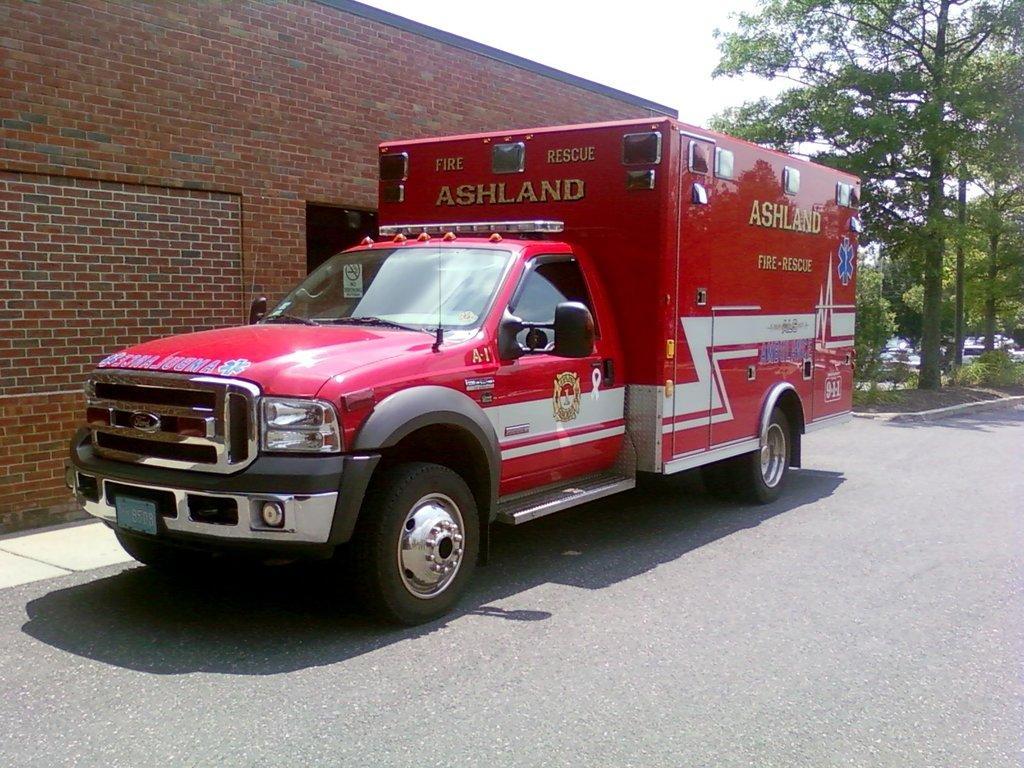Could you give a brief overview of what you see in this image? This picture is clicked outside the city. In this picture, we see a vehicle in red color is parked on the road. Beside that, we see a building which is made up of brown color bricks. There are trees in the background. At the top of the picture, we see the sky. At the bottom of the picture, we see the road. 